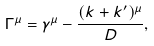Convert formula to latex. <formula><loc_0><loc_0><loc_500><loc_500>\Gamma ^ { \mu } = \gamma ^ { \mu } - \frac { ( k + k ^ { \prime } ) ^ { \mu } } { D } ,</formula> 